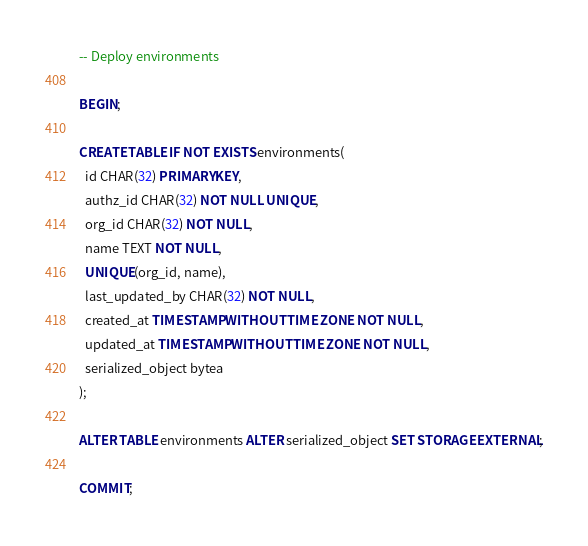Convert code to text. <code><loc_0><loc_0><loc_500><loc_500><_SQL_>-- Deploy environments

BEGIN;

CREATE TABLE IF NOT EXISTS environments(
  id CHAR(32) PRIMARY KEY,
  authz_id CHAR(32) NOT NULL UNIQUE,
  org_id CHAR(32) NOT NULL,
  name TEXT NOT NULL,
  UNIQUE(org_id, name),
  last_updated_by CHAR(32) NOT NULL,
  created_at TIMESTAMP WITHOUT TIME ZONE NOT NULL,
  updated_at TIMESTAMP WITHOUT TIME ZONE NOT NULL,
  serialized_object bytea
);

ALTER TABLE environments ALTER serialized_object SET STORAGE EXTERNAL;

COMMIT;
</code> 